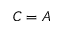Convert formula to latex. <formula><loc_0><loc_0><loc_500><loc_500>C = A</formula> 